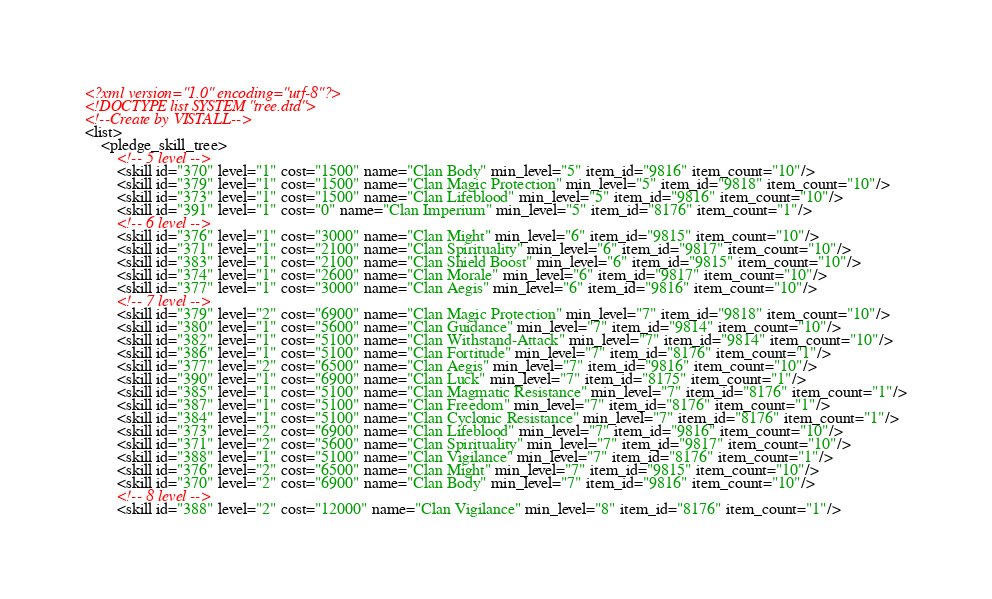Convert code to text. <code><loc_0><loc_0><loc_500><loc_500><_XML_><?xml version="1.0" encoding="utf-8"?>
<!DOCTYPE list SYSTEM "tree.dtd">
<!--Create by VISTALL-->
<list>
	<pledge_skill_tree>
		<!-- 5 level -->
		<skill id="370" level="1" cost="1500" name="Clan Body" min_level="5" item_id="9816" item_count="10"/>
		<skill id="379" level="1" cost="1500" name="Clan Magic Protection" min_level="5" item_id="9818" item_count="10"/>
		<skill id="373" level="1" cost="1500" name="Clan Lifeblood" min_level="5" item_id="9816" item_count="10"/>
		<skill id="391" level="1" cost="0" name="Clan Imperium" min_level="5" item_id="8176" item_count="1"/>
		<!-- 6 level -->
		<skill id="376" level="1" cost="3000" name="Clan Might" min_level="6" item_id="9815" item_count="10"/>
		<skill id="371" level="1" cost="2100" name="Clan Spirituality" min_level="6" item_id="9817" item_count="10"/>
		<skill id="383" level="1" cost="2100" name="Clan Shield Boost" min_level="6" item_id="9815" item_count="10"/>
		<skill id="374" level="1" cost="2600" name="Clan Morale" min_level="6" item_id="9817" item_count="10"/>
		<skill id="377" level="1" cost="3000" name="Clan Aegis" min_level="6" item_id="9816" item_count="10"/>
		<!-- 7 level -->
		<skill id="379" level="2" cost="6900" name="Clan Magic Protection" min_level="7" item_id="9818" item_count="10"/>
		<skill id="380" level="1" cost="5600" name="Clan Guidance" min_level="7" item_id="9814" item_count="10"/>
		<skill id="382" level="1" cost="5100" name="Clan Withstand-Attack" min_level="7" item_id="9814" item_count="10"/>
		<skill id="386" level="1" cost="5100" name="Clan Fortitude" min_level="7" item_id="8176" item_count="1"/>
		<skill id="377" level="2" cost="6500" name="Clan Aegis" min_level="7" item_id="9816" item_count="10"/>
		<skill id="390" level="1" cost="6900" name="Clan Luck" min_level="7" item_id="8175" item_count="1"/>
		<skill id="385" level="1" cost="5100" name="Clan Magmatic Resistance" min_level="7" item_id="8176" item_count="1"/>
		<skill id="387" level="1" cost="5100" name="Clan Freedom" min_level="7" item_id="8176" item_count="1"/>
		<skill id="384" level="1" cost="5100" name="Clan Cyclonic Resistance" min_level="7" item_id="8176" item_count="1"/>
		<skill id="373" level="2" cost="6900" name="Clan Lifeblood" min_level="7" item_id="9816" item_count="10"/>
		<skill id="371" level="2" cost="5600" name="Clan Spirituality" min_level="7" item_id="9817" item_count="10"/>
		<skill id="388" level="1" cost="5100" name="Clan Vigilance" min_level="7" item_id="8176" item_count="1"/>
		<skill id="376" level="2" cost="6500" name="Clan Might" min_level="7" item_id="9815" item_count="10"/>
		<skill id="370" level="2" cost="6900" name="Clan Body" min_level="7" item_id="9816" item_count="10"/>
		<!-- 8 level -->
		<skill id="388" level="2" cost="12000" name="Clan Vigilance" min_level="8" item_id="8176" item_count="1"/></code> 